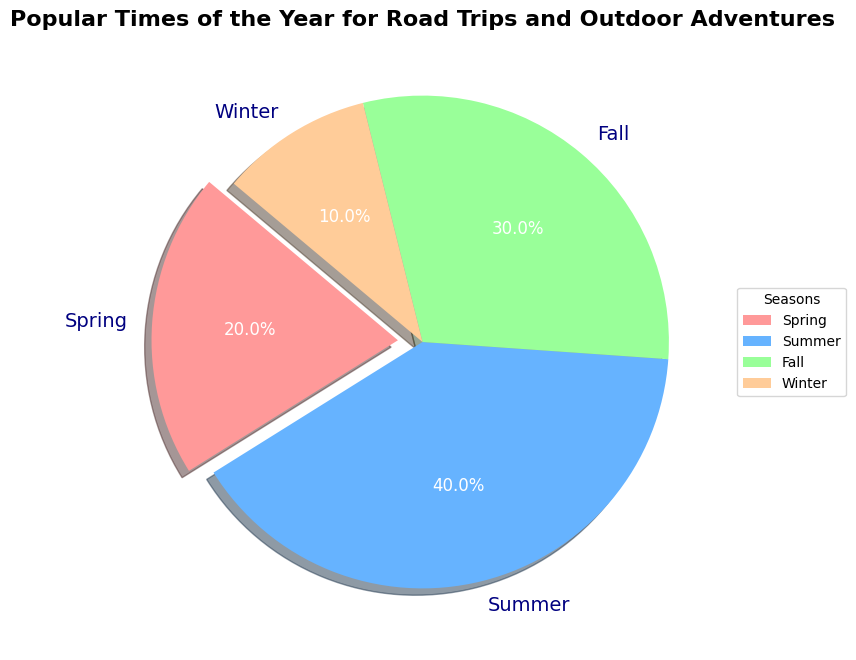What season has the highest percentage of popular times for road trips and outdoor adventures? Look at the section of the pie chart and identify which one has the largest slice. The Summer slice is the largest at 40%.
Answer: Summer Which season is the least popular for road trips and outdoor adventures? Look at the sections of the pie chart and identify the smallest slice. The Winter slice is the smallest at 10%.
Answer: Winter How much more popular is Spring compared to Winter? Subtract the percentage of Winter from the percentage of Spring: 20% - 10% = 10%.
Answer: 10% What's the combined popularity percentage of Spring and Fall? Add the percentage of Spring to the percentage of Fall: 20% + 30% = 50%.
Answer: 50% Which two seasons combined equal the popularity of Summer? Identify which two slices add up to Summer's 40%. Spring and Fall together share 20% + 30% = 50%, which is not correct. Instead, combining Spring and Winter is 20% + 10% = 30%, again not right. Combining Fall and Winter, 30% + 10% = 40% matches Summer’s percentage.
Answer: Fall and Winter Is Fall more or less popular than Spring? Compare the sizes of the Fall and Spring slices in the pie chart. Fall is 30%, which is greater than Spring at 20%.
Answer: More How many times is Summer more popular than Winter? Divide the percentage of Summer by the percentage of Winter: 40% / 10% = 4.
Answer: 4 Which seasons have a combined popularity of 60%? Identify which combination of the slices equals 60%. Summer and Fall together are 40% + 30% = 70%, which is not right. Spring and Fall combined are 20% + 30% = 50%, not accurate either. Instead, Summer and Spring combined equates to 40% + 20% = 60%.
Answer: Summer and Spring What color represents the least popular season for road trips and outdoor adventures? Identify the Winter slice, which is colored either red, blue, green, or yellow. Winter is represented by yellow.
Answer: Yellow 